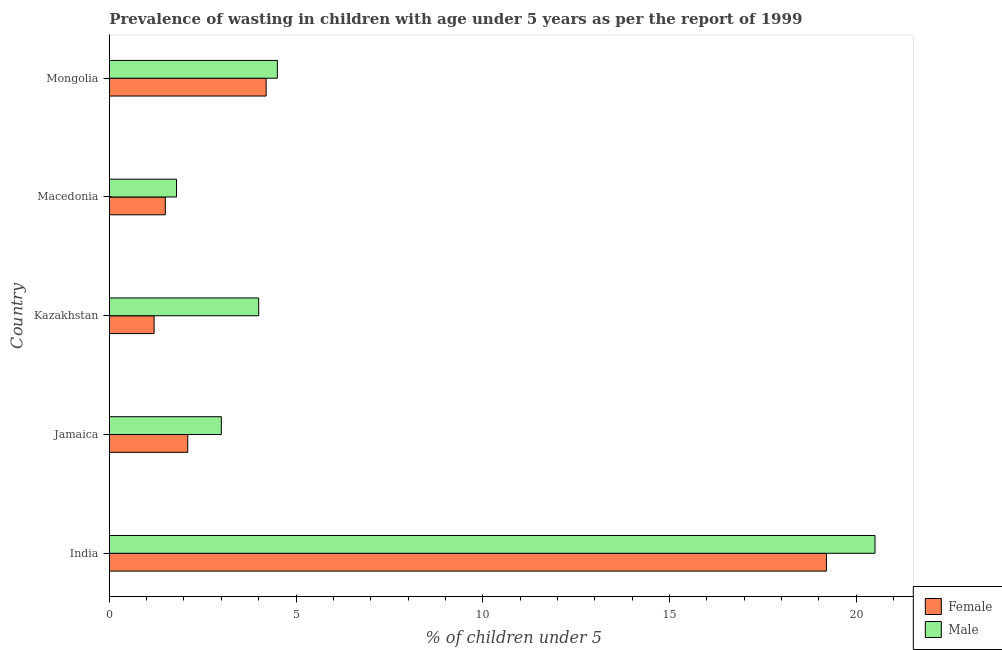How many different coloured bars are there?
Ensure brevity in your answer.  2. Are the number of bars on each tick of the Y-axis equal?
Your response must be concise. Yes. How many bars are there on the 5th tick from the bottom?
Give a very brief answer. 2. What is the label of the 1st group of bars from the top?
Ensure brevity in your answer.  Mongolia. In how many cases, is the number of bars for a given country not equal to the number of legend labels?
Offer a very short reply. 0. Across all countries, what is the maximum percentage of undernourished male children?
Give a very brief answer. 20.5. Across all countries, what is the minimum percentage of undernourished female children?
Offer a very short reply. 1.2. In which country was the percentage of undernourished female children minimum?
Offer a terse response. Kazakhstan. What is the total percentage of undernourished male children in the graph?
Provide a short and direct response. 33.8. What is the difference between the percentage of undernourished female children in Kazakhstan and the percentage of undernourished male children in Jamaica?
Give a very brief answer. -1.8. What is the average percentage of undernourished female children per country?
Keep it short and to the point. 5.64. What is the ratio of the percentage of undernourished male children in Macedonia to that in Mongolia?
Keep it short and to the point. 0.4. Is the difference between the percentage of undernourished female children in Jamaica and Kazakhstan greater than the difference between the percentage of undernourished male children in Jamaica and Kazakhstan?
Your answer should be compact. Yes. What is the difference between the highest and the second highest percentage of undernourished female children?
Offer a very short reply. 15. What is the difference between the highest and the lowest percentage of undernourished female children?
Your answer should be compact. 18. Is the sum of the percentage of undernourished male children in Jamaica and Mongolia greater than the maximum percentage of undernourished female children across all countries?
Ensure brevity in your answer.  No. What does the 1st bar from the bottom in Macedonia represents?
Keep it short and to the point. Female. Are the values on the major ticks of X-axis written in scientific E-notation?
Give a very brief answer. No. Does the graph contain any zero values?
Offer a very short reply. No. Does the graph contain grids?
Your answer should be compact. No. Where does the legend appear in the graph?
Your response must be concise. Bottom right. How are the legend labels stacked?
Your response must be concise. Vertical. What is the title of the graph?
Ensure brevity in your answer.  Prevalence of wasting in children with age under 5 years as per the report of 1999. What is the label or title of the X-axis?
Your answer should be very brief.  % of children under 5. What is the  % of children under 5 in Female in India?
Keep it short and to the point. 19.2. What is the  % of children under 5 in Female in Jamaica?
Offer a terse response. 2.1. What is the  % of children under 5 in Female in Kazakhstan?
Your response must be concise. 1.2. What is the  % of children under 5 of Male in Kazakhstan?
Offer a very short reply. 4. What is the  % of children under 5 of Female in Macedonia?
Your answer should be compact. 1.5. What is the  % of children under 5 in Male in Macedonia?
Your response must be concise. 1.8. What is the  % of children under 5 of Female in Mongolia?
Your answer should be compact. 4.2. Across all countries, what is the maximum  % of children under 5 in Female?
Provide a short and direct response. 19.2. Across all countries, what is the minimum  % of children under 5 in Female?
Offer a terse response. 1.2. Across all countries, what is the minimum  % of children under 5 of Male?
Ensure brevity in your answer.  1.8. What is the total  % of children under 5 in Female in the graph?
Ensure brevity in your answer.  28.2. What is the total  % of children under 5 in Male in the graph?
Offer a terse response. 33.8. What is the difference between the  % of children under 5 in Male in India and that in Jamaica?
Ensure brevity in your answer.  17.5. What is the difference between the  % of children under 5 of Female in India and that in Kazakhstan?
Keep it short and to the point. 18. What is the difference between the  % of children under 5 in Female in India and that in Macedonia?
Offer a very short reply. 17.7. What is the difference between the  % of children under 5 in Male in India and that in Mongolia?
Offer a terse response. 16. What is the difference between the  % of children under 5 of Female in Kazakhstan and that in Mongolia?
Your response must be concise. -3. What is the difference between the  % of children under 5 of Female in India and the  % of children under 5 of Male in Jamaica?
Keep it short and to the point. 16.2. What is the difference between the  % of children under 5 in Female in India and the  % of children under 5 in Male in Kazakhstan?
Ensure brevity in your answer.  15.2. What is the difference between the  % of children under 5 of Female in India and the  % of children under 5 of Male in Mongolia?
Ensure brevity in your answer.  14.7. What is the difference between the  % of children under 5 in Female in Jamaica and the  % of children under 5 in Male in Kazakhstan?
Provide a short and direct response. -1.9. What is the difference between the  % of children under 5 of Female in Jamaica and the  % of children under 5 of Male in Macedonia?
Provide a succinct answer. 0.3. What is the difference between the  % of children under 5 of Female in Kazakhstan and the  % of children under 5 of Male in Macedonia?
Keep it short and to the point. -0.6. What is the difference between the  % of children under 5 in Female in Kazakhstan and the  % of children under 5 in Male in Mongolia?
Make the answer very short. -3.3. What is the average  % of children under 5 of Female per country?
Keep it short and to the point. 5.64. What is the average  % of children under 5 in Male per country?
Provide a succinct answer. 6.76. What is the difference between the  % of children under 5 in Female and  % of children under 5 in Male in India?
Make the answer very short. -1.3. What is the difference between the  % of children under 5 in Female and  % of children under 5 in Male in Mongolia?
Offer a very short reply. -0.3. What is the ratio of the  % of children under 5 in Female in India to that in Jamaica?
Provide a succinct answer. 9.14. What is the ratio of the  % of children under 5 in Male in India to that in Jamaica?
Provide a short and direct response. 6.83. What is the ratio of the  % of children under 5 of Male in India to that in Kazakhstan?
Provide a short and direct response. 5.12. What is the ratio of the  % of children under 5 in Male in India to that in Macedonia?
Make the answer very short. 11.39. What is the ratio of the  % of children under 5 of Female in India to that in Mongolia?
Give a very brief answer. 4.57. What is the ratio of the  % of children under 5 of Male in India to that in Mongolia?
Make the answer very short. 4.56. What is the ratio of the  % of children under 5 in Female in Jamaica to that in Mongolia?
Provide a short and direct response. 0.5. What is the ratio of the  % of children under 5 in Male in Kazakhstan to that in Macedonia?
Your response must be concise. 2.22. What is the ratio of the  % of children under 5 in Female in Kazakhstan to that in Mongolia?
Your answer should be compact. 0.29. What is the ratio of the  % of children under 5 in Male in Kazakhstan to that in Mongolia?
Your answer should be compact. 0.89. What is the ratio of the  % of children under 5 in Female in Macedonia to that in Mongolia?
Your response must be concise. 0.36. What is the difference between the highest and the second highest  % of children under 5 of Female?
Keep it short and to the point. 15. What is the difference between the highest and the second highest  % of children under 5 of Male?
Keep it short and to the point. 16. What is the difference between the highest and the lowest  % of children under 5 of Male?
Provide a short and direct response. 18.7. 